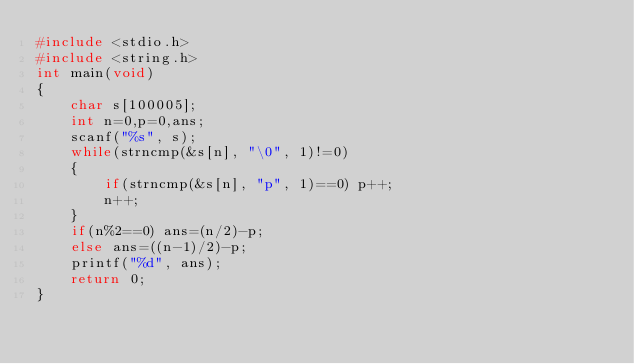Convert code to text. <code><loc_0><loc_0><loc_500><loc_500><_C_>#include <stdio.h>
#include <string.h>
int main(void)
{
    char s[100005];
    int n=0,p=0,ans;
    scanf("%s", s);
    while(strncmp(&s[n], "\0", 1)!=0)
    {
        if(strncmp(&s[n], "p", 1)==0) p++;
        n++;
    }
    if(n%2==0) ans=(n/2)-p;
    else ans=((n-1)/2)-p;
    printf("%d", ans);
    return 0;
}</code> 